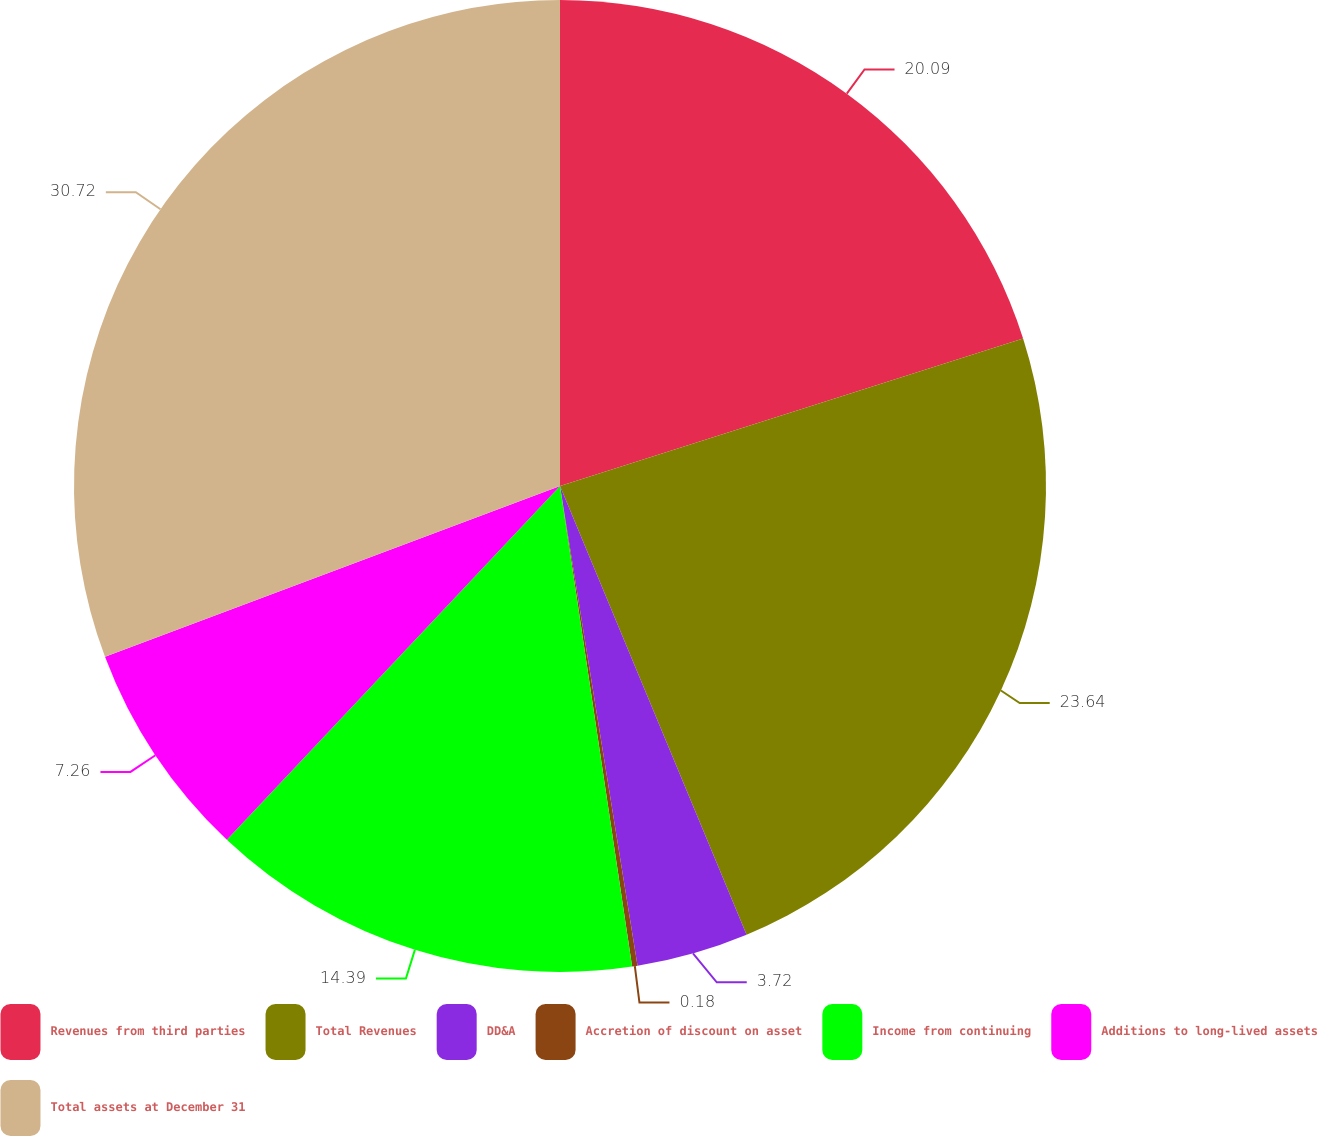Convert chart. <chart><loc_0><loc_0><loc_500><loc_500><pie_chart><fcel>Revenues from third parties<fcel>Total Revenues<fcel>DD&A<fcel>Accretion of discount on asset<fcel>Income from continuing<fcel>Additions to long-lived assets<fcel>Total assets at December 31<nl><fcel>20.09%<fcel>23.63%<fcel>3.72%<fcel>0.18%<fcel>14.39%<fcel>7.26%<fcel>30.71%<nl></chart> 